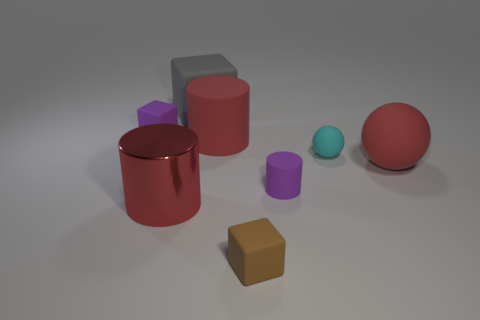There is a big red metal object; are there any tiny brown blocks behind it?
Your answer should be very brief. No. How many large matte cubes are in front of the tiny purple rubber object in front of the small cyan matte ball?
Offer a very short reply. 0. Do the brown thing and the ball that is behind the red ball have the same size?
Keep it short and to the point. Yes. Are there any other objects that have the same color as the big shiny object?
Keep it short and to the point. Yes. What size is the red cylinder that is made of the same material as the small purple cylinder?
Offer a terse response. Large. There is a tiny rubber block that is behind the cube in front of the block that is left of the big metallic object; what color is it?
Make the answer very short. Purple. The big red shiny object has what shape?
Keep it short and to the point. Cylinder. Do the big metallic cylinder and the big thing on the right side of the tiny cyan ball have the same color?
Keep it short and to the point. Yes. Is the number of gray objects on the right side of the big red matte cylinder the same as the number of tiny gray shiny balls?
Provide a succinct answer. Yes. What number of rubber objects have the same size as the purple cylinder?
Ensure brevity in your answer.  3. 